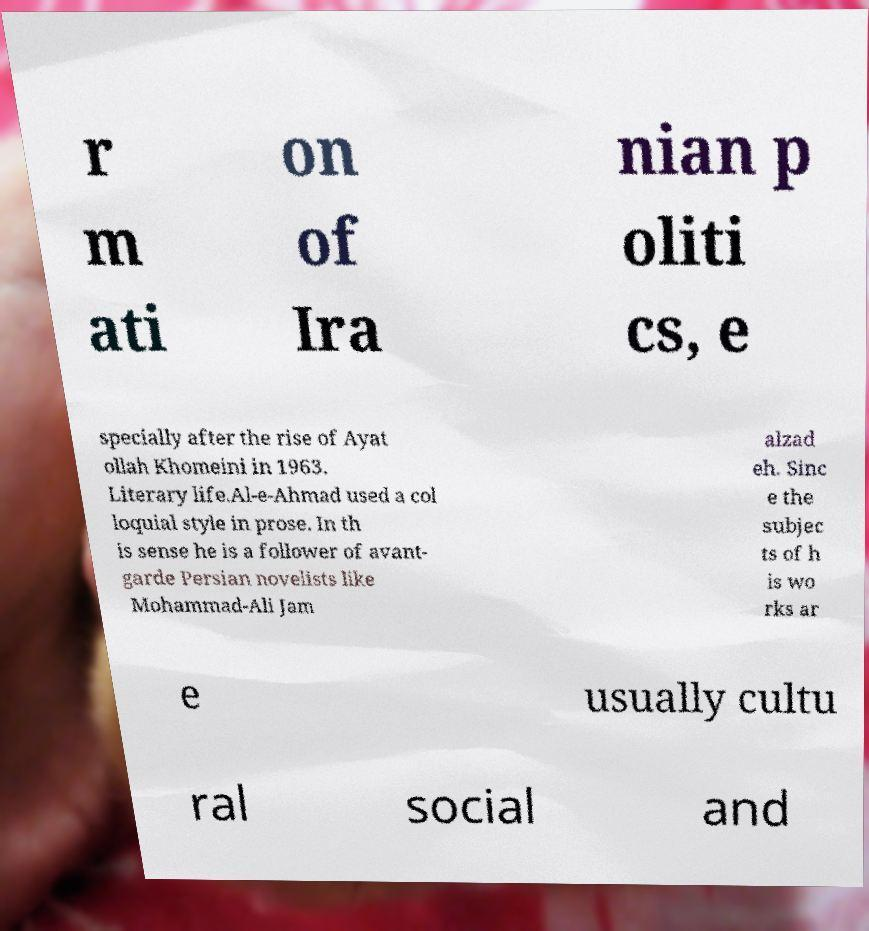Can you read and provide the text displayed in the image?This photo seems to have some interesting text. Can you extract and type it out for me? r m ati on of Ira nian p oliti cs, e specially after the rise of Ayat ollah Khomeini in 1963. Literary life.Al-e-Ahmad used a col loquial style in prose. In th is sense he is a follower of avant- garde Persian novelists like Mohammad-Ali Jam alzad eh. Sinc e the subjec ts of h is wo rks ar e usually cultu ral social and 